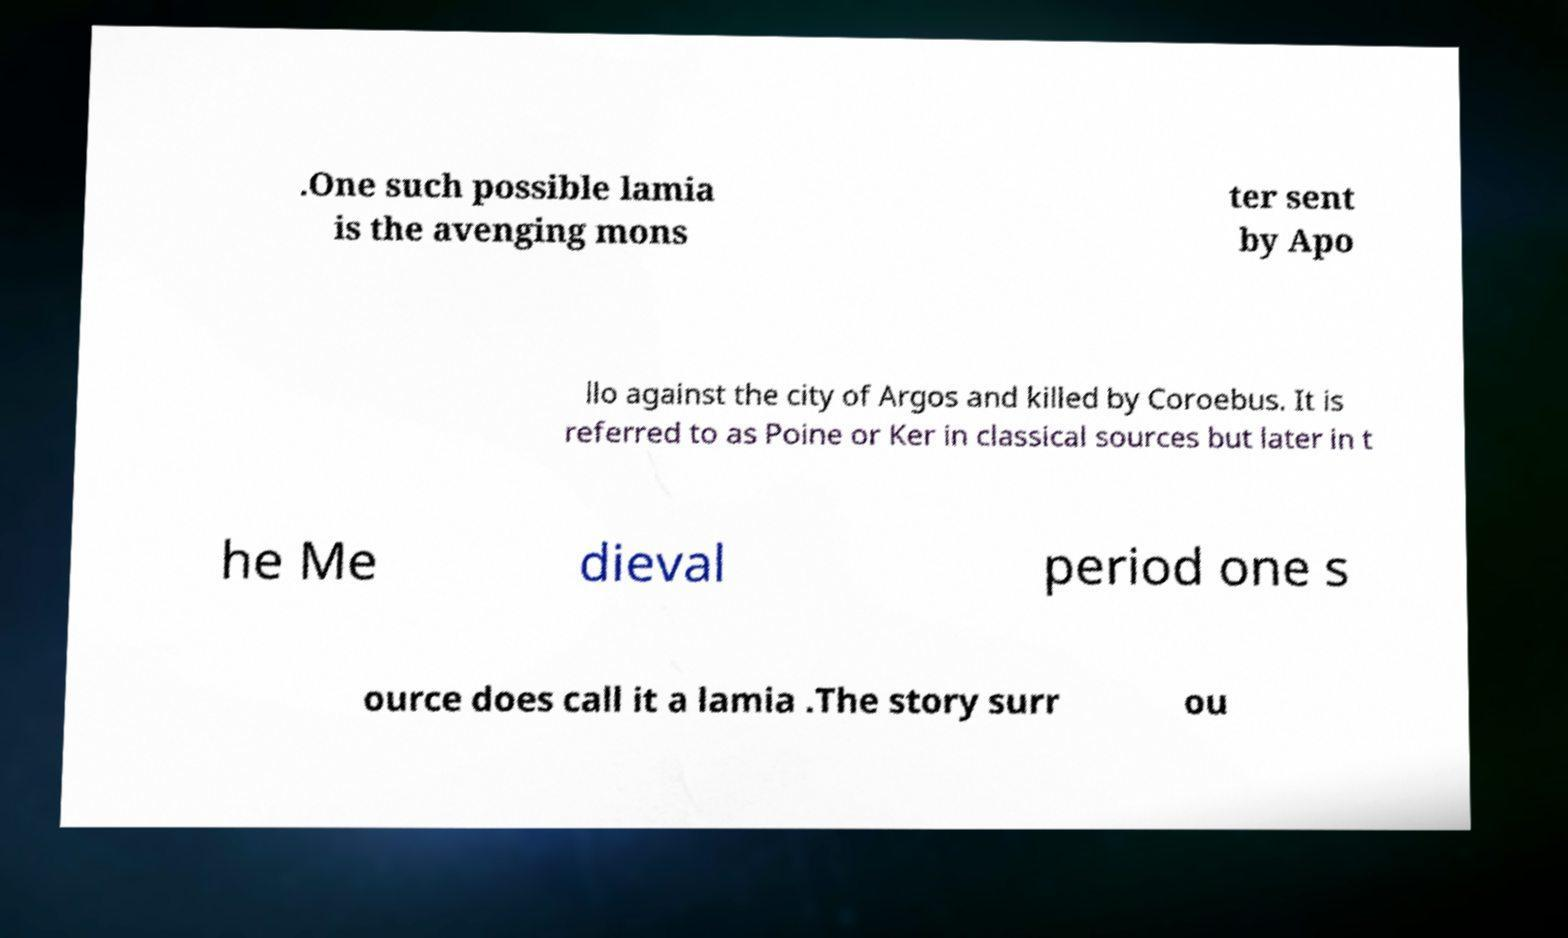There's text embedded in this image that I need extracted. Can you transcribe it verbatim? .One such possible lamia is the avenging mons ter sent by Apo llo against the city of Argos and killed by Coroebus. It is referred to as Poine or Ker in classical sources but later in t he Me dieval period one s ource does call it a lamia .The story surr ou 